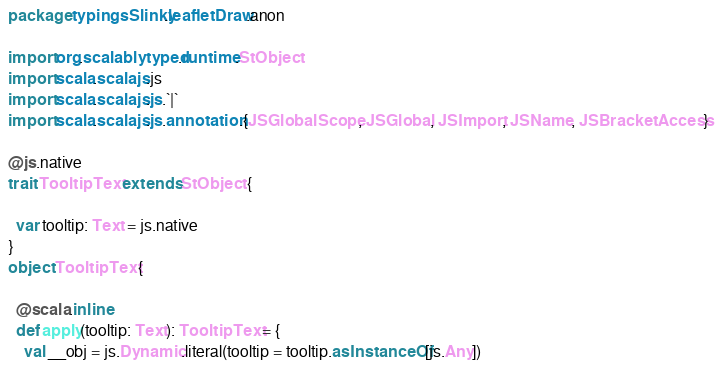<code> <loc_0><loc_0><loc_500><loc_500><_Scala_>package typingsSlinky.leafletDraw.anon

import org.scalablytyped.runtime.StObject
import scala.scalajs.js
import scala.scalajs.js.`|`
import scala.scalajs.js.annotation.{JSGlobalScope, JSGlobal, JSImport, JSName, JSBracketAccess}

@js.native
trait TooltipText extends StObject {
  
  var tooltip: Text = js.native
}
object TooltipText {
  
  @scala.inline
  def apply(tooltip: Text): TooltipText = {
    val __obj = js.Dynamic.literal(tooltip = tooltip.asInstanceOf[js.Any])</code> 